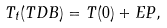<formula> <loc_0><loc_0><loc_500><loc_500>T _ { t } ( T D B ) = T ( 0 ) + E P ,</formula> 